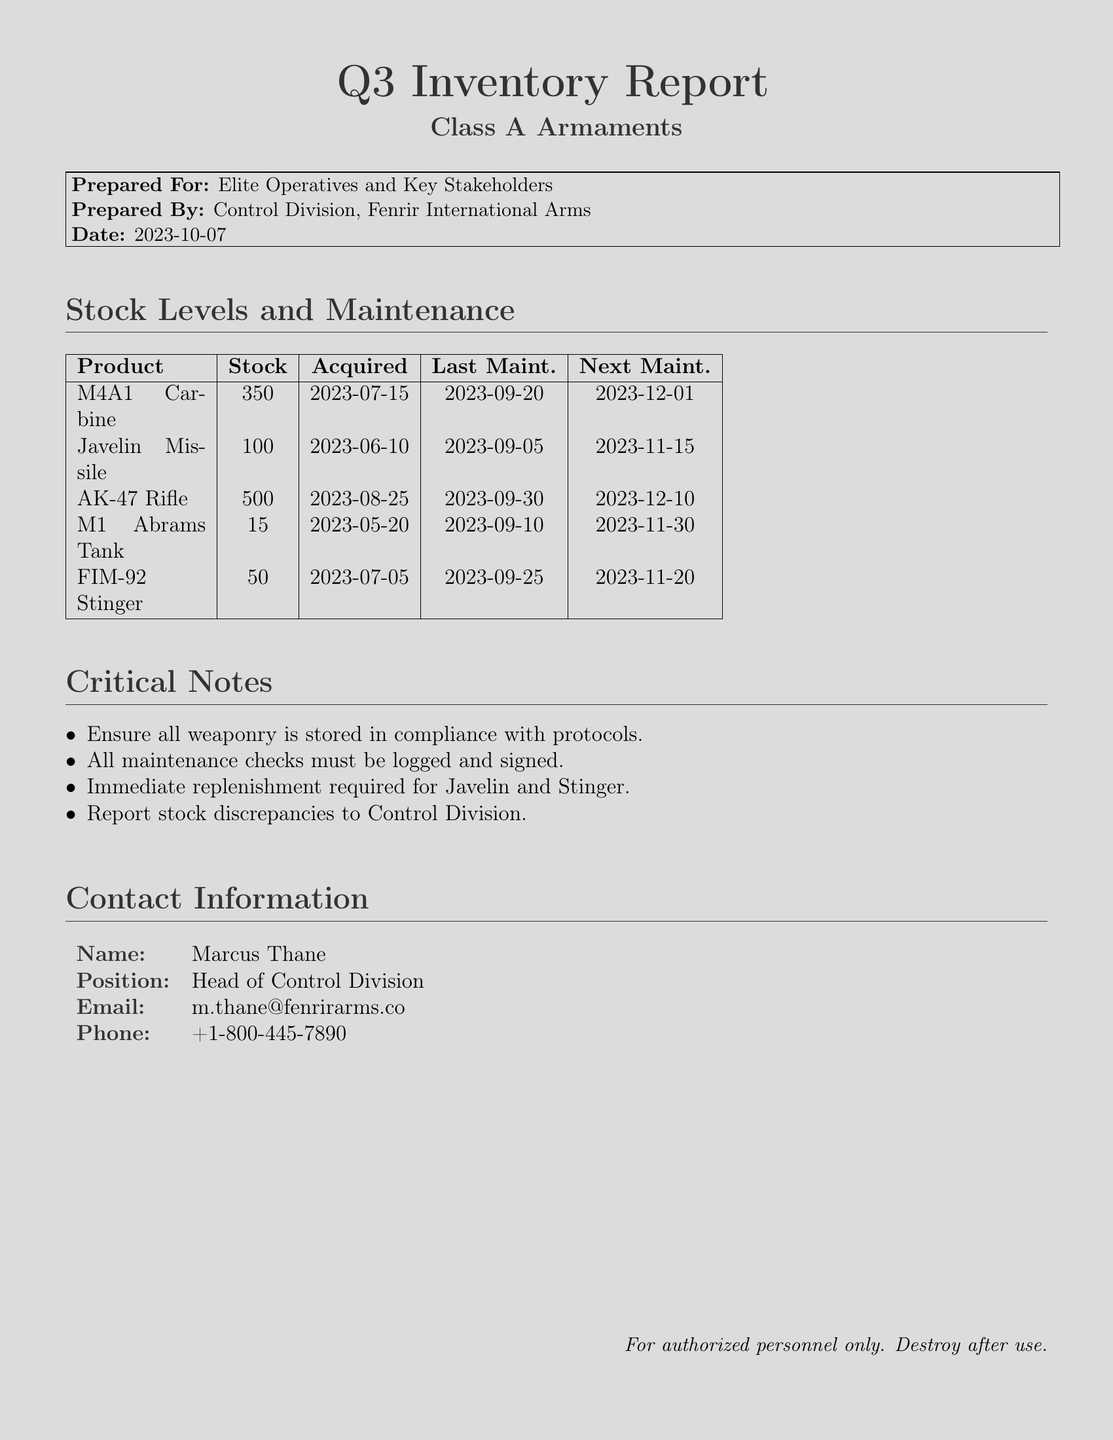What is the date of the report? The report was prepared on 2023-10-07 as stated in the section labeled "Prepared By".
Answer: 2023-10-07 How many M4A1 Carbines are in stock? The stock level for the M4A1 Carbine is reported in the table under "Stock".
Answer: 350 When was the last maintenance for the Javelin Missile? The last maintenance date for the Javelin Missile can be found in the "Last Maint." column of the table.
Answer: 2023-09-05 What is the next maintenance date for the AK-47 Rifle? The next maintenance date is indicated in the "Next Maint." column of the inventory table.
Answer: 2023-12-10 What is the total stock of Class A Armaments listed? The total stock can be calculated by summing the "Stock" column values in the table.
Answer: 1015 How many days are left until the next maintenance of the M1 Abrams Tank? This requires calculating the days from the current date to the next maintenance date listed for the M1 Abrams Tank.
Answer: 54 days What item requires immediate replenishment? The "Critical Notes" section states the items that require immediate replenishment.
Answer: Javelin and Stinger Who is the Head of Control Division? The name of the Head of Control Division is clearly stated in the contact information section.
Answer: Marcus Thane What is the email address of Marcus Thane? This information is provided in the contact details section under "Email".
Answer: m.thane@fenrirarms.co 